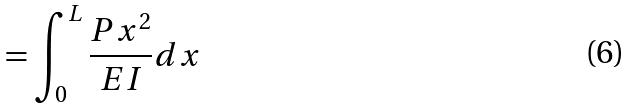<formula> <loc_0><loc_0><loc_500><loc_500>= \int _ { 0 } ^ { L } \frac { P x ^ { 2 } } { E I } d x</formula> 